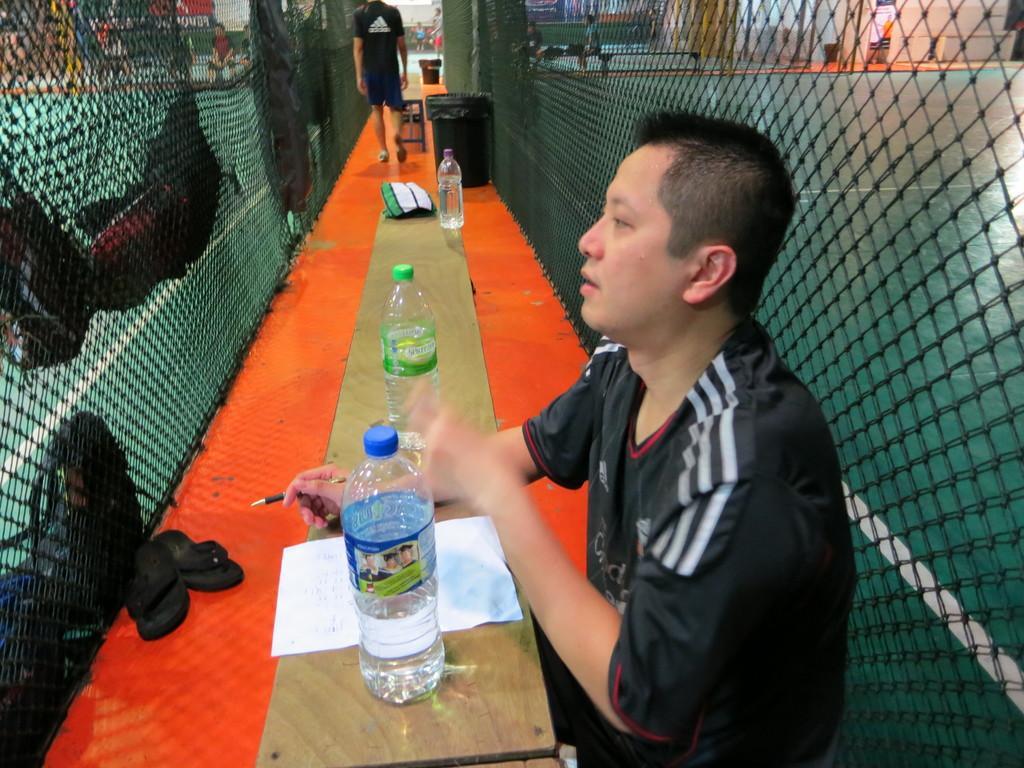In one or two sentences, can you explain what this image depicts? In this image I see a man who is sitting in front of a table and there are 3 bottles and a paper on it. I can also see there are slippers and net and a person over here. In the background I can see few people and the wall. 